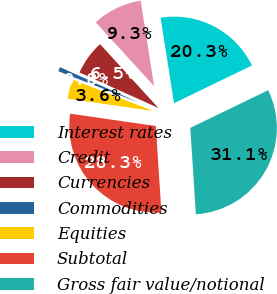<chart> <loc_0><loc_0><loc_500><loc_500><pie_chart><fcel>Interest rates<fcel>Credit<fcel>Currencies<fcel>Commodities<fcel>Equities<fcel>Subtotal<fcel>Gross fair value/notional<nl><fcel>20.3%<fcel>9.31%<fcel>6.48%<fcel>0.81%<fcel>3.64%<fcel>28.31%<fcel>31.15%<nl></chart> 